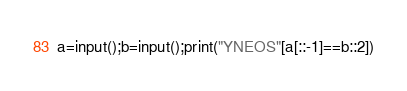Convert code to text. <code><loc_0><loc_0><loc_500><loc_500><_Python_>a=input();b=input();print("YNEOS"[a[::-1]==b::2])</code> 